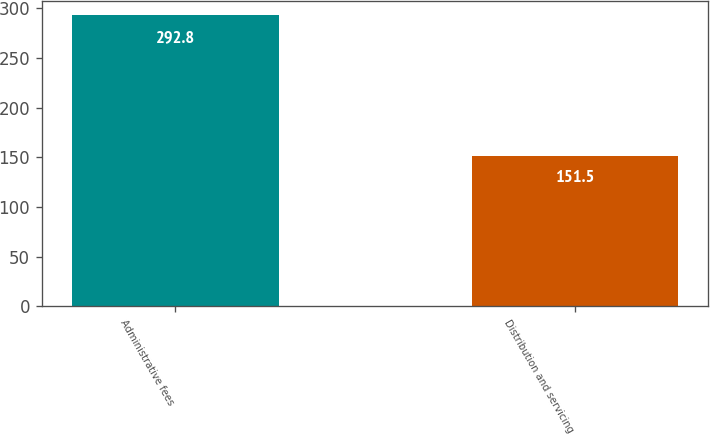Convert chart. <chart><loc_0><loc_0><loc_500><loc_500><bar_chart><fcel>Administrative fees<fcel>Distribution and servicing<nl><fcel>292.8<fcel>151.5<nl></chart> 